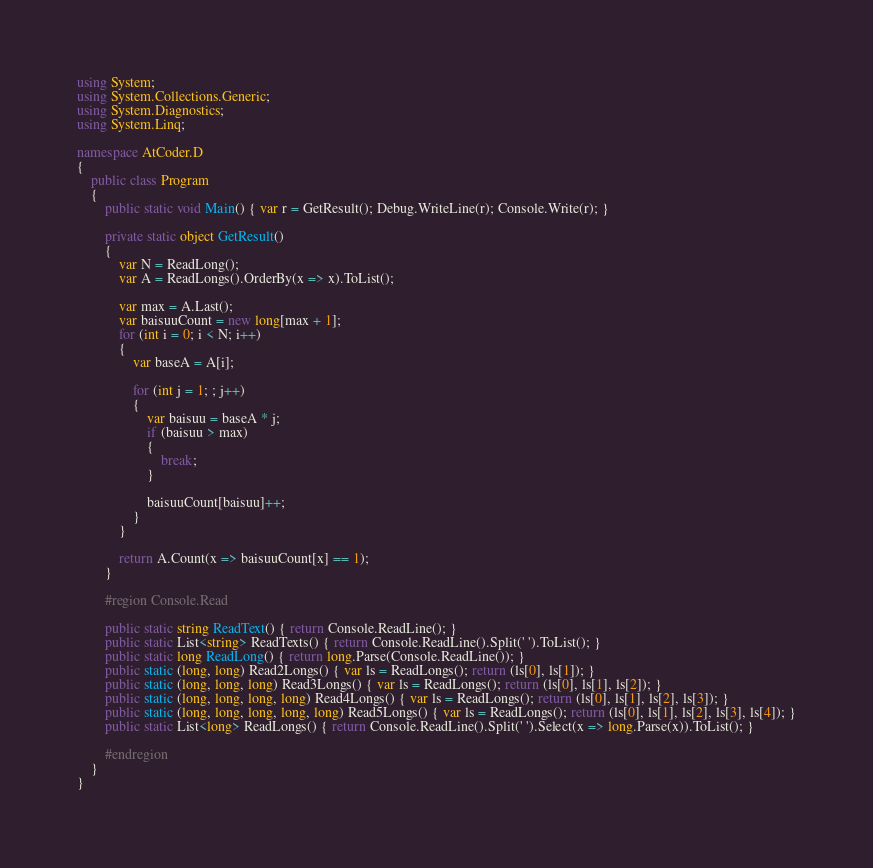Convert code to text. <code><loc_0><loc_0><loc_500><loc_500><_C#_>using System;
using System.Collections.Generic;
using System.Diagnostics;
using System.Linq;

namespace AtCoder.D
{
    public class Program
    {
        public static void Main() { var r = GetResult(); Debug.WriteLine(r); Console.Write(r); }

        private static object GetResult()
        {
            var N = ReadLong();
            var A = ReadLongs().OrderBy(x => x).ToList();

            var max = A.Last();
            var baisuuCount = new long[max + 1];
            for (int i = 0; i < N; i++)
            {
                var baseA = A[i];

                for (int j = 1; ; j++)
                {
                    var baisuu = baseA * j;
                    if (baisuu > max)
                    {
                        break;
                    }

                    baisuuCount[baisuu]++;
                }
            }

            return A.Count(x => baisuuCount[x] == 1);
        }

        #region Console.Read

        public static string ReadText() { return Console.ReadLine(); }
        public static List<string> ReadTexts() { return Console.ReadLine().Split(' ').ToList(); }
        public static long ReadLong() { return long.Parse(Console.ReadLine()); }
        public static (long, long) Read2Longs() { var ls = ReadLongs(); return (ls[0], ls[1]); }
        public static (long, long, long) Read3Longs() { var ls = ReadLongs(); return (ls[0], ls[1], ls[2]); }
        public static (long, long, long, long) Read4Longs() { var ls = ReadLongs(); return (ls[0], ls[1], ls[2], ls[3]); }
        public static (long, long, long, long, long) Read5Longs() { var ls = ReadLongs(); return (ls[0], ls[1], ls[2], ls[3], ls[4]); }
        public static List<long> ReadLongs() { return Console.ReadLine().Split(' ').Select(x => long.Parse(x)).ToList(); }

        #endregion
    }
}
</code> 